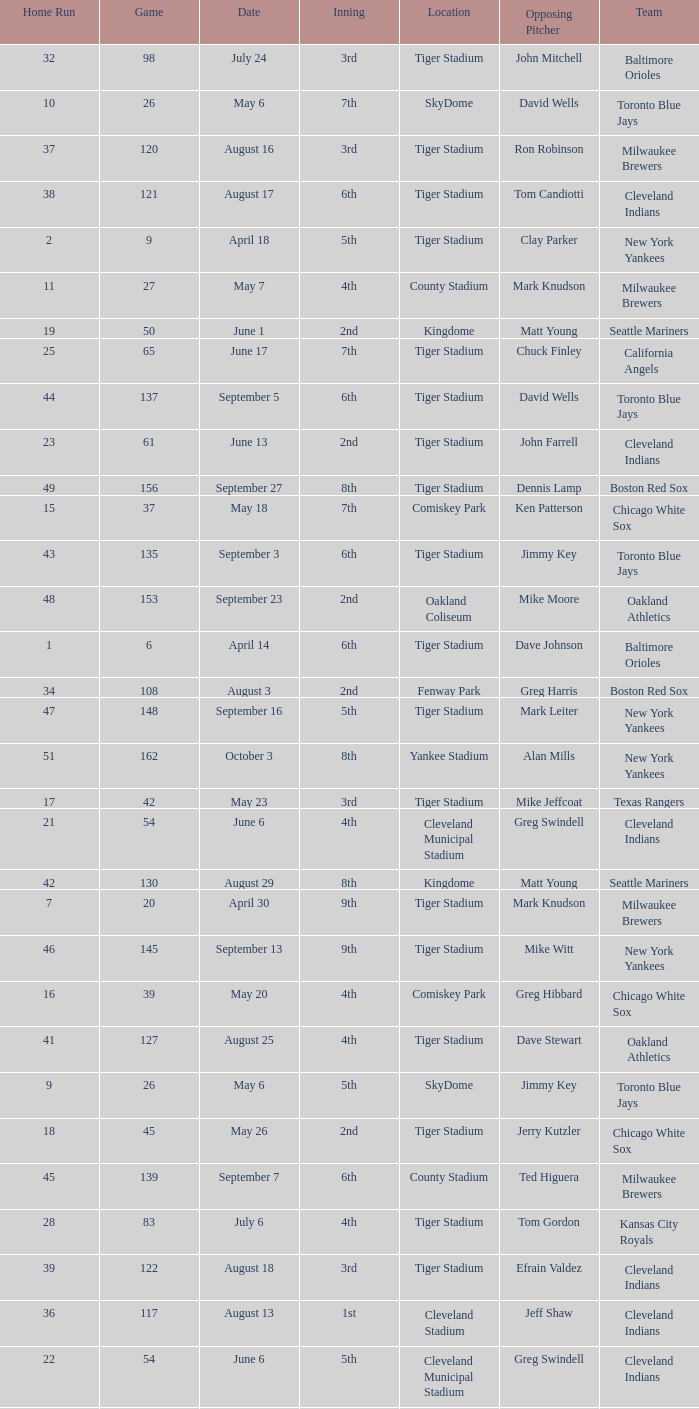What was the average number of home runs at tiger stadium on june 17th? 25.0. 